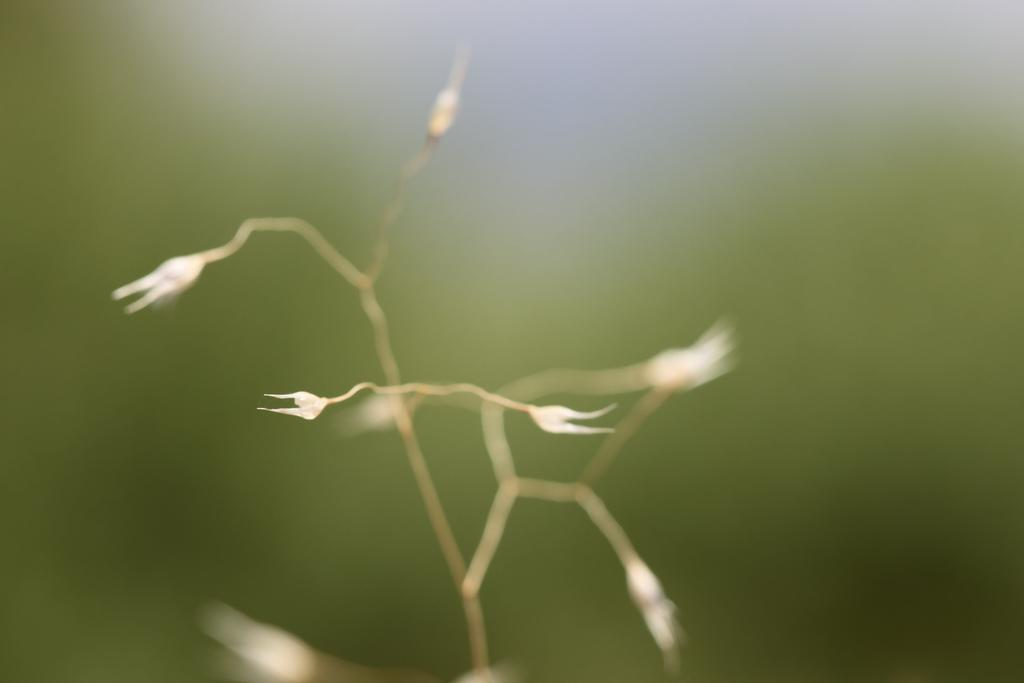What is present in the image? There is a plant in the image. What can be observed about the plant? The plant has flowers. What type of paint is being used to color the train in the image? There is no train present in the image, so it is not possible to determine what type of paint might be used. 